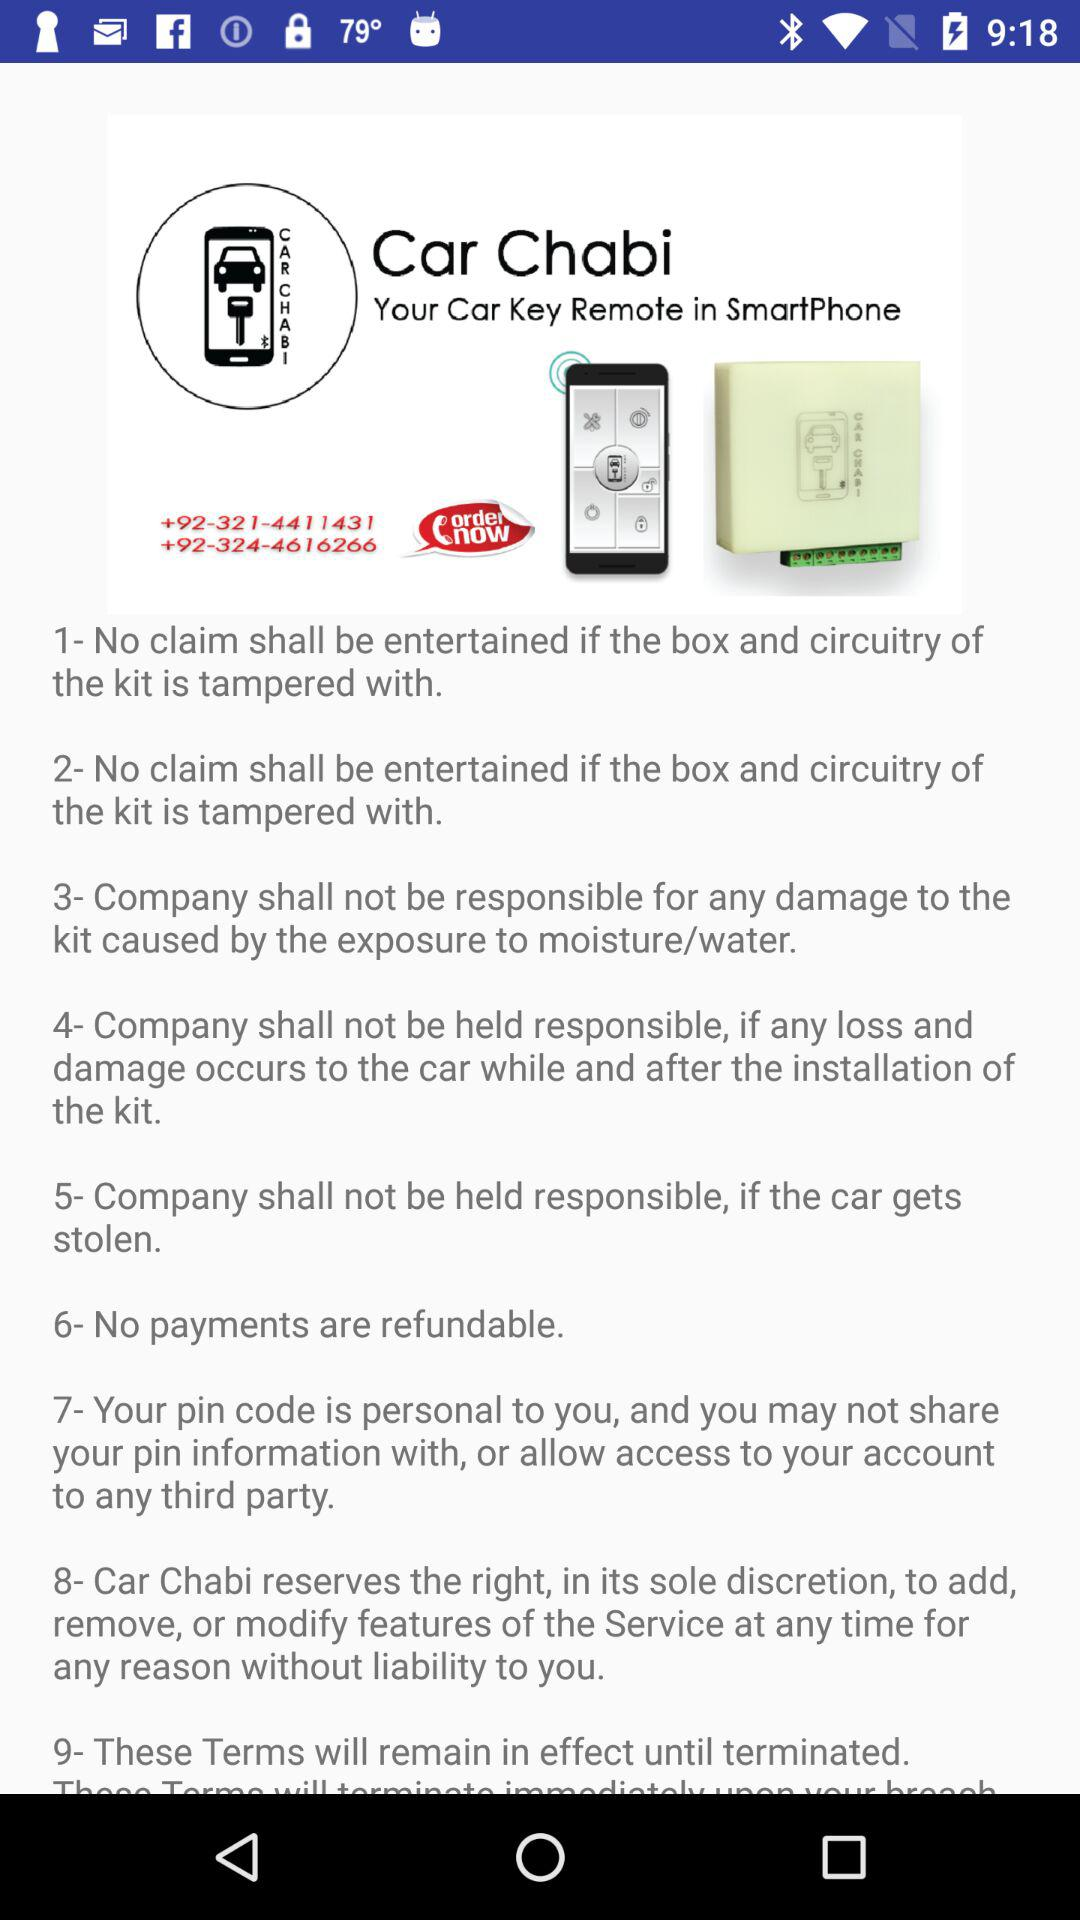What are the given contact numbers to order? The given contact numbers are +92-321-4411431 and +92-324-4616266. 